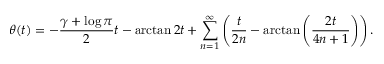Convert formula to latex. <formula><loc_0><loc_0><loc_500><loc_500>\theta ( t ) = - { \frac { \gamma + \log \pi } { 2 } } t - \arctan 2 t + \sum _ { n = 1 } ^ { \infty } \left ( { \frac { t } { 2 n } } - \arctan \left ( { \frac { 2 t } { 4 n + 1 } } \right ) \right ) .</formula> 